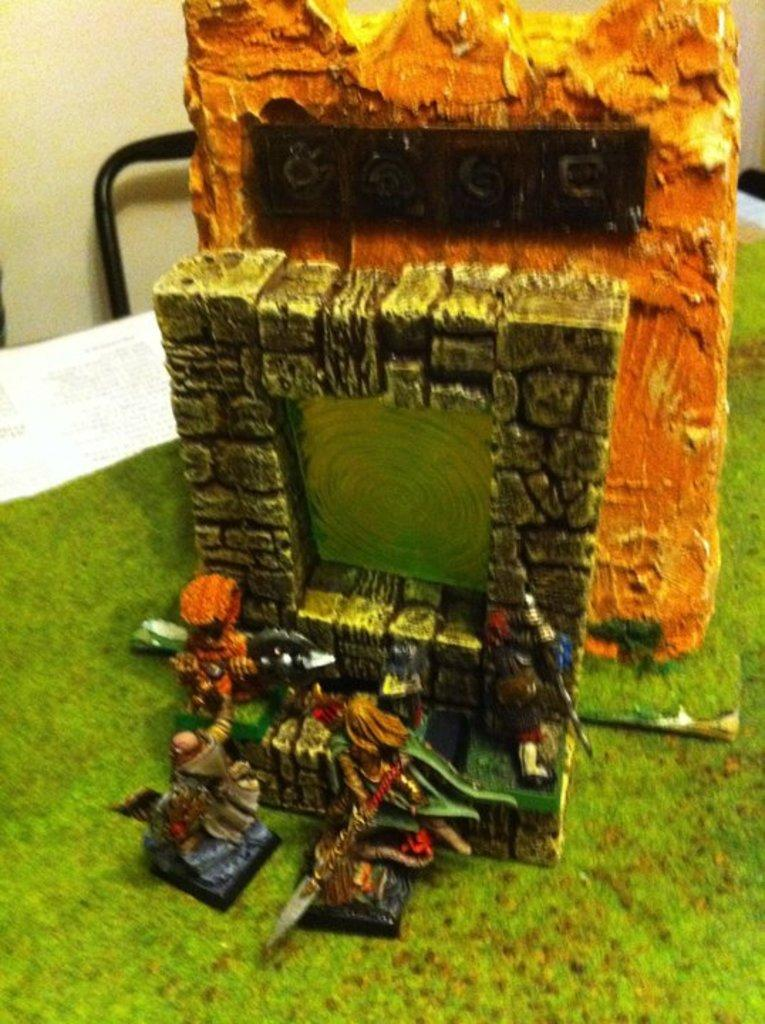What type of objects can be seen in the image? There are colorful objects in the image. How big are the objects in the image? The objects are miniature in size. Are there any toy figures in the image? Yes, there are toy people in the image. What is the color of the surface on which the objects and toy people are placed? The objects and toy people are on a green and white color surface. What color is the background of the image? The background of the image is cream-colored. What arithmetic problem can be solved using the soap in the image? There is no soap present in the image, and therefore no arithmetic problem can be solved using it. 